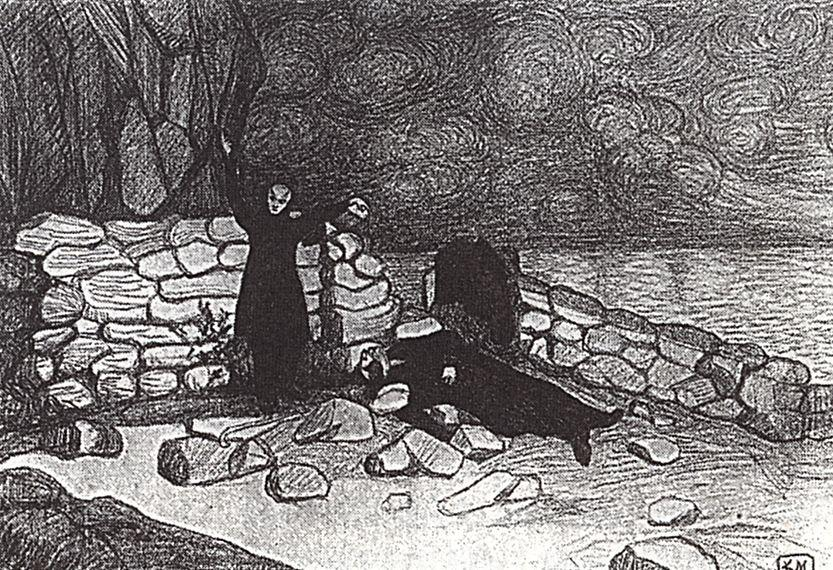What could be the historical significance of this location? This sketch could depict a historically significant coastal area, possibly used as a lookout or a hermit's retreat given the secluded stone building and strategic view of the waters. Such locations often double as places of reflection or defense throughout history, adding layers of narrative about human interaction with natural landscapes over time. 